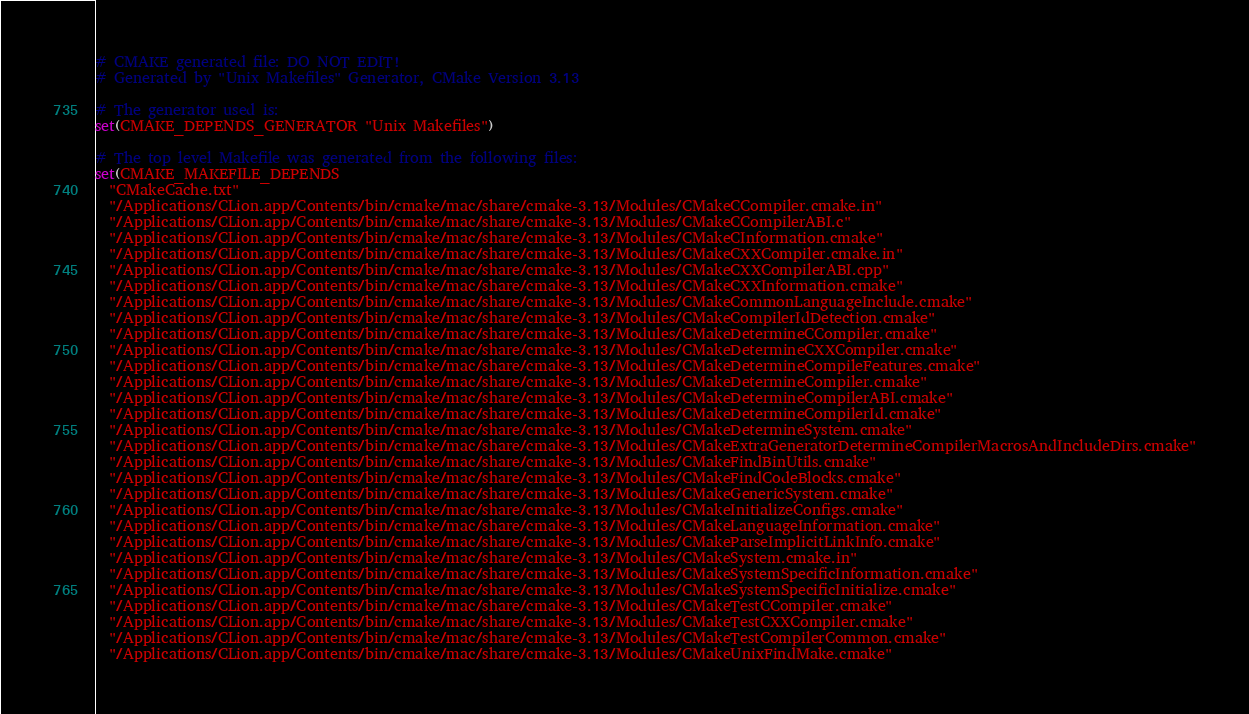Convert code to text. <code><loc_0><loc_0><loc_500><loc_500><_CMake_># CMAKE generated file: DO NOT EDIT!
# Generated by "Unix Makefiles" Generator, CMake Version 3.13

# The generator used is:
set(CMAKE_DEPENDS_GENERATOR "Unix Makefiles")

# The top level Makefile was generated from the following files:
set(CMAKE_MAKEFILE_DEPENDS
  "CMakeCache.txt"
  "/Applications/CLion.app/Contents/bin/cmake/mac/share/cmake-3.13/Modules/CMakeCCompiler.cmake.in"
  "/Applications/CLion.app/Contents/bin/cmake/mac/share/cmake-3.13/Modules/CMakeCCompilerABI.c"
  "/Applications/CLion.app/Contents/bin/cmake/mac/share/cmake-3.13/Modules/CMakeCInformation.cmake"
  "/Applications/CLion.app/Contents/bin/cmake/mac/share/cmake-3.13/Modules/CMakeCXXCompiler.cmake.in"
  "/Applications/CLion.app/Contents/bin/cmake/mac/share/cmake-3.13/Modules/CMakeCXXCompilerABI.cpp"
  "/Applications/CLion.app/Contents/bin/cmake/mac/share/cmake-3.13/Modules/CMakeCXXInformation.cmake"
  "/Applications/CLion.app/Contents/bin/cmake/mac/share/cmake-3.13/Modules/CMakeCommonLanguageInclude.cmake"
  "/Applications/CLion.app/Contents/bin/cmake/mac/share/cmake-3.13/Modules/CMakeCompilerIdDetection.cmake"
  "/Applications/CLion.app/Contents/bin/cmake/mac/share/cmake-3.13/Modules/CMakeDetermineCCompiler.cmake"
  "/Applications/CLion.app/Contents/bin/cmake/mac/share/cmake-3.13/Modules/CMakeDetermineCXXCompiler.cmake"
  "/Applications/CLion.app/Contents/bin/cmake/mac/share/cmake-3.13/Modules/CMakeDetermineCompileFeatures.cmake"
  "/Applications/CLion.app/Contents/bin/cmake/mac/share/cmake-3.13/Modules/CMakeDetermineCompiler.cmake"
  "/Applications/CLion.app/Contents/bin/cmake/mac/share/cmake-3.13/Modules/CMakeDetermineCompilerABI.cmake"
  "/Applications/CLion.app/Contents/bin/cmake/mac/share/cmake-3.13/Modules/CMakeDetermineCompilerId.cmake"
  "/Applications/CLion.app/Contents/bin/cmake/mac/share/cmake-3.13/Modules/CMakeDetermineSystem.cmake"
  "/Applications/CLion.app/Contents/bin/cmake/mac/share/cmake-3.13/Modules/CMakeExtraGeneratorDetermineCompilerMacrosAndIncludeDirs.cmake"
  "/Applications/CLion.app/Contents/bin/cmake/mac/share/cmake-3.13/Modules/CMakeFindBinUtils.cmake"
  "/Applications/CLion.app/Contents/bin/cmake/mac/share/cmake-3.13/Modules/CMakeFindCodeBlocks.cmake"
  "/Applications/CLion.app/Contents/bin/cmake/mac/share/cmake-3.13/Modules/CMakeGenericSystem.cmake"
  "/Applications/CLion.app/Contents/bin/cmake/mac/share/cmake-3.13/Modules/CMakeInitializeConfigs.cmake"
  "/Applications/CLion.app/Contents/bin/cmake/mac/share/cmake-3.13/Modules/CMakeLanguageInformation.cmake"
  "/Applications/CLion.app/Contents/bin/cmake/mac/share/cmake-3.13/Modules/CMakeParseImplicitLinkInfo.cmake"
  "/Applications/CLion.app/Contents/bin/cmake/mac/share/cmake-3.13/Modules/CMakeSystem.cmake.in"
  "/Applications/CLion.app/Contents/bin/cmake/mac/share/cmake-3.13/Modules/CMakeSystemSpecificInformation.cmake"
  "/Applications/CLion.app/Contents/bin/cmake/mac/share/cmake-3.13/Modules/CMakeSystemSpecificInitialize.cmake"
  "/Applications/CLion.app/Contents/bin/cmake/mac/share/cmake-3.13/Modules/CMakeTestCCompiler.cmake"
  "/Applications/CLion.app/Contents/bin/cmake/mac/share/cmake-3.13/Modules/CMakeTestCXXCompiler.cmake"
  "/Applications/CLion.app/Contents/bin/cmake/mac/share/cmake-3.13/Modules/CMakeTestCompilerCommon.cmake"
  "/Applications/CLion.app/Contents/bin/cmake/mac/share/cmake-3.13/Modules/CMakeUnixFindMake.cmake"</code> 